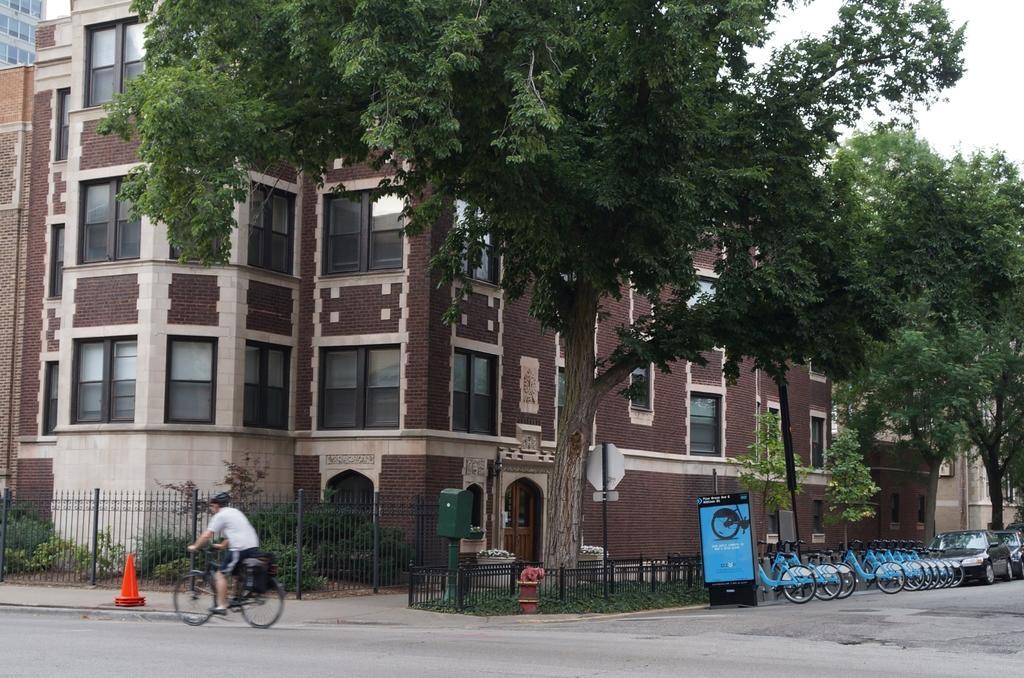Please provide a concise description of this image. In the center of the image there is a building. There are trees. At the bottom of the image there is road. There are bicycles. There are vehicles. There is a person riding a bicycle. There is a fencing. There is a safety cone. 